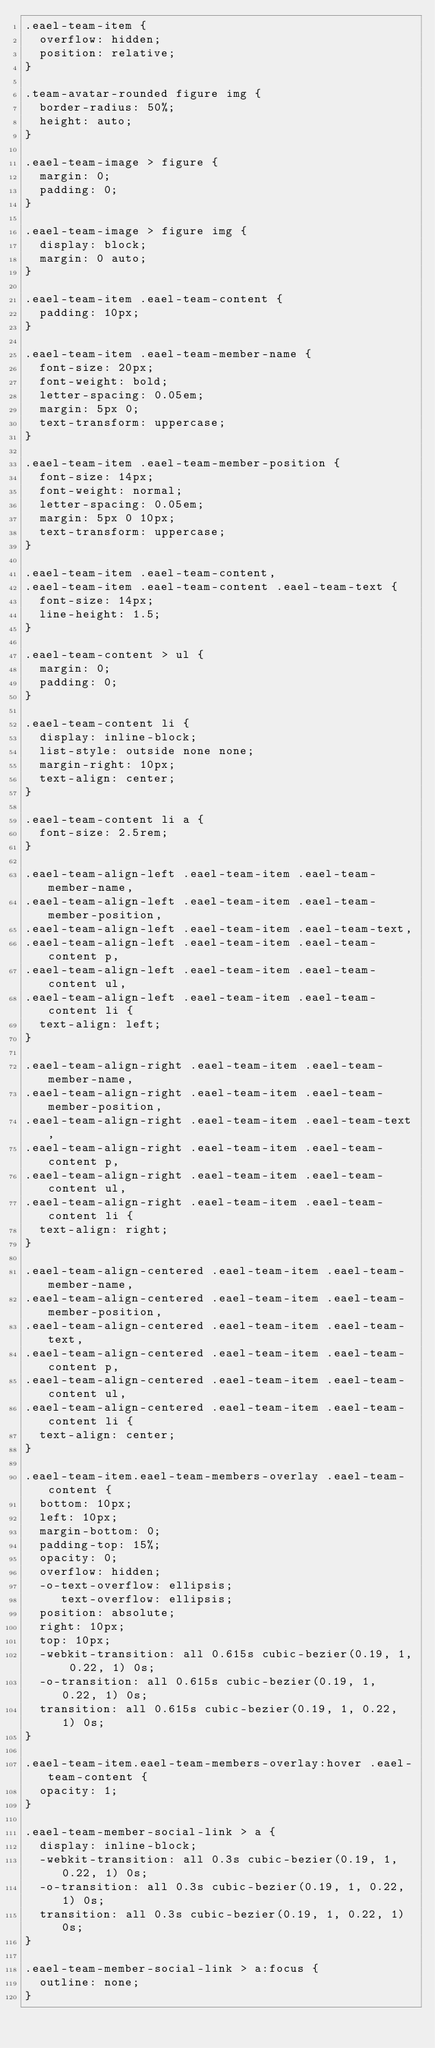Convert code to text. <code><loc_0><loc_0><loc_500><loc_500><_CSS_>.eael-team-item {
  overflow: hidden;
  position: relative;
}

.team-avatar-rounded figure img {
  border-radius: 50%;
  height: auto;
}

.eael-team-image > figure {
  margin: 0;
  padding: 0;
}

.eael-team-image > figure img {
  display: block;
  margin: 0 auto;
}

.eael-team-item .eael-team-content {
  padding: 10px;
}

.eael-team-item .eael-team-member-name {
  font-size: 20px;
  font-weight: bold;
  letter-spacing: 0.05em;
  margin: 5px 0;
  text-transform: uppercase;
}

.eael-team-item .eael-team-member-position {
  font-size: 14px;
  font-weight: normal;
  letter-spacing: 0.05em;
  margin: 5px 0 10px;
  text-transform: uppercase;
}

.eael-team-item .eael-team-content,
.eael-team-item .eael-team-content .eael-team-text {
  font-size: 14px;
  line-height: 1.5;
}

.eael-team-content > ul {
  margin: 0;
  padding: 0;
}

.eael-team-content li {
  display: inline-block;
  list-style: outside none none;
  margin-right: 10px;
  text-align: center;
}

.eael-team-content li a {
  font-size: 2.5rem;
}

.eael-team-align-left .eael-team-item .eael-team-member-name,
.eael-team-align-left .eael-team-item .eael-team-member-position,
.eael-team-align-left .eael-team-item .eael-team-text,
.eael-team-align-left .eael-team-item .eael-team-content p,
.eael-team-align-left .eael-team-item .eael-team-content ul,
.eael-team-align-left .eael-team-item .eael-team-content li {
  text-align: left;
}

.eael-team-align-right .eael-team-item .eael-team-member-name,
.eael-team-align-right .eael-team-item .eael-team-member-position,
.eael-team-align-right .eael-team-item .eael-team-text,
.eael-team-align-right .eael-team-item .eael-team-content p,
.eael-team-align-right .eael-team-item .eael-team-content ul,
.eael-team-align-right .eael-team-item .eael-team-content li {
  text-align: right;
}

.eael-team-align-centered .eael-team-item .eael-team-member-name,
.eael-team-align-centered .eael-team-item .eael-team-member-position,
.eael-team-align-centered .eael-team-item .eael-team-text,
.eael-team-align-centered .eael-team-item .eael-team-content p,
.eael-team-align-centered .eael-team-item .eael-team-content ul,
.eael-team-align-centered .eael-team-item .eael-team-content li {
  text-align: center;
}

.eael-team-item.eael-team-members-overlay .eael-team-content {
  bottom: 10px;
  left: 10px;
  margin-bottom: 0;
  padding-top: 15%;
  opacity: 0;
  overflow: hidden;
  -o-text-overflow: ellipsis;
     text-overflow: ellipsis;
  position: absolute;
  right: 10px;
  top: 10px;
  -webkit-transition: all 0.615s cubic-bezier(0.19, 1, 0.22, 1) 0s;
  -o-transition: all 0.615s cubic-bezier(0.19, 1, 0.22, 1) 0s;
  transition: all 0.615s cubic-bezier(0.19, 1, 0.22, 1) 0s;
}

.eael-team-item.eael-team-members-overlay:hover .eael-team-content {
  opacity: 1;
}

.eael-team-member-social-link > a {
  display: inline-block;
  -webkit-transition: all 0.3s cubic-bezier(0.19, 1, 0.22, 1) 0s;
  -o-transition: all 0.3s cubic-bezier(0.19, 1, 0.22, 1) 0s;
  transition: all 0.3s cubic-bezier(0.19, 1, 0.22, 1) 0s;
}

.eael-team-member-social-link > a:focus {
  outline: none;
}
</code> 